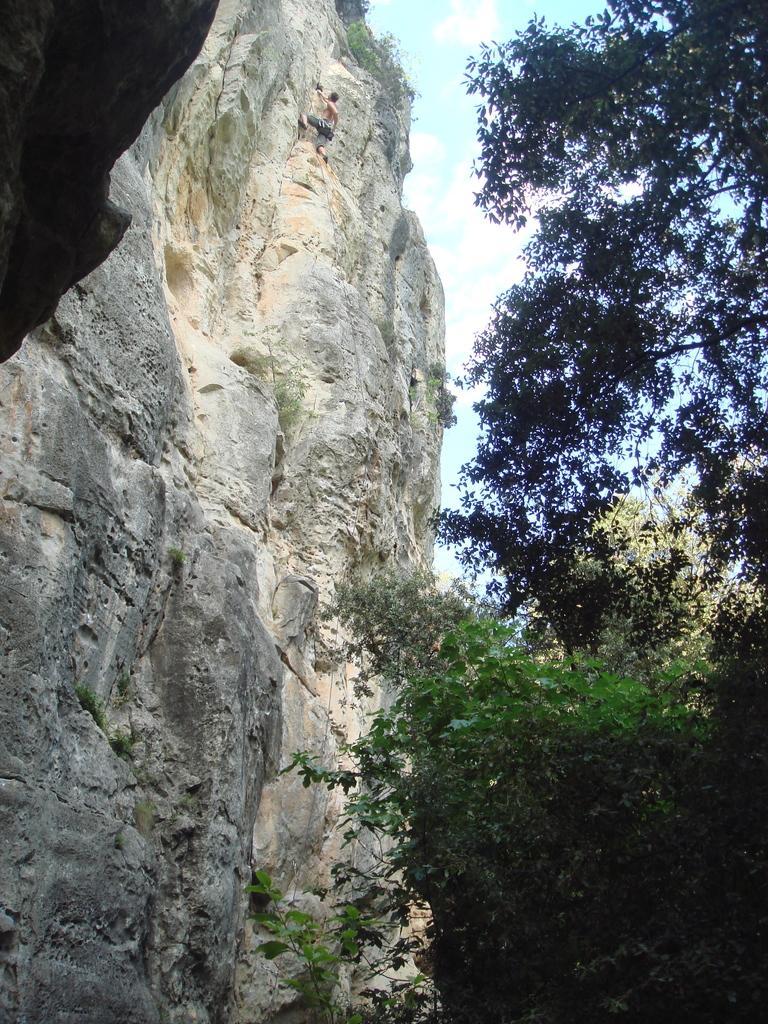Could you give a brief overview of what you see in this image? In this picture I can see trees, mountain and sky. I can also see a person climbing on the mountain. 